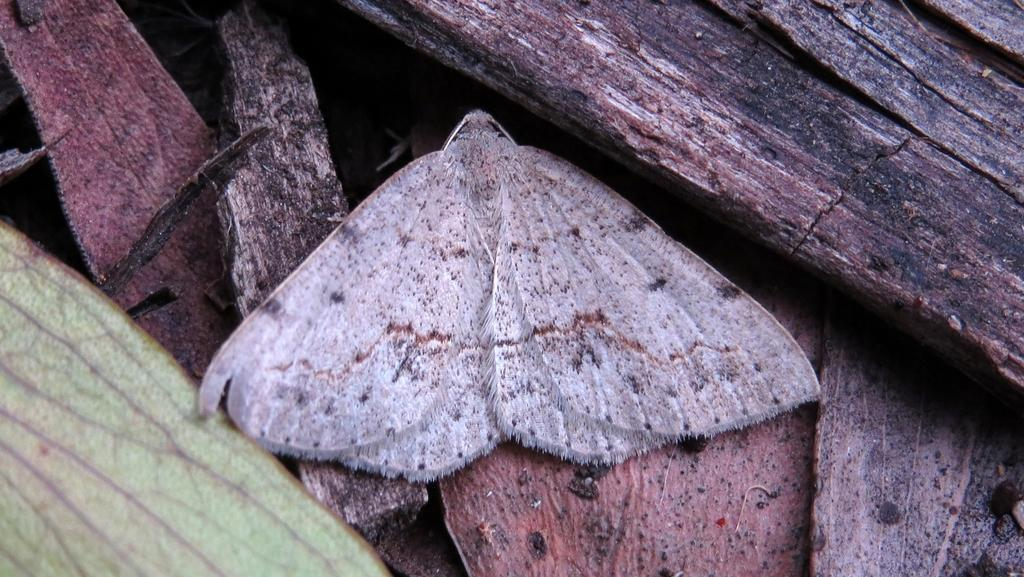What type of creature is in the picture? There is an insect in the picture. What color is the insect? The insect is grey in color. Where is the insect located? The insect is in the woods. What colors can be seen in the woods? The woods have black and brown colors. Can you tell me how many flies are running around the basin in the image? There are no flies or basin present in the image; it features an insect in the woods. 